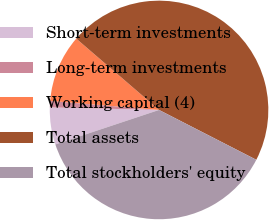<chart> <loc_0><loc_0><loc_500><loc_500><pie_chart><fcel>Short-term investments<fcel>Long-term investments<fcel>Working capital (4)<fcel>Total assets<fcel>Total stockholders' equity<nl><fcel>5.48%<fcel>0.95%<fcel>10.0%<fcel>46.22%<fcel>37.35%<nl></chart> 